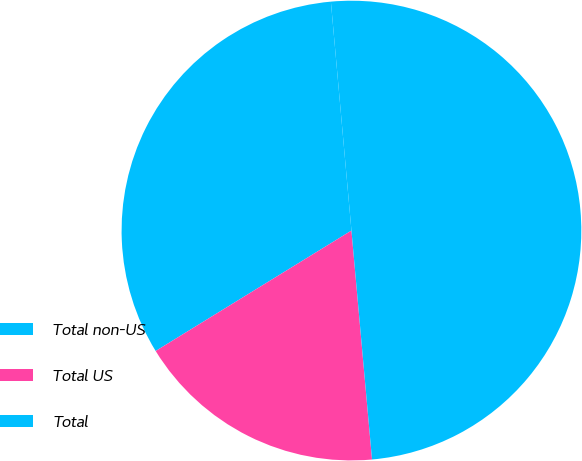Convert chart. <chart><loc_0><loc_0><loc_500><loc_500><pie_chart><fcel>Total non-US<fcel>Total US<fcel>Total<nl><fcel>32.35%<fcel>17.65%<fcel>50.0%<nl></chart> 